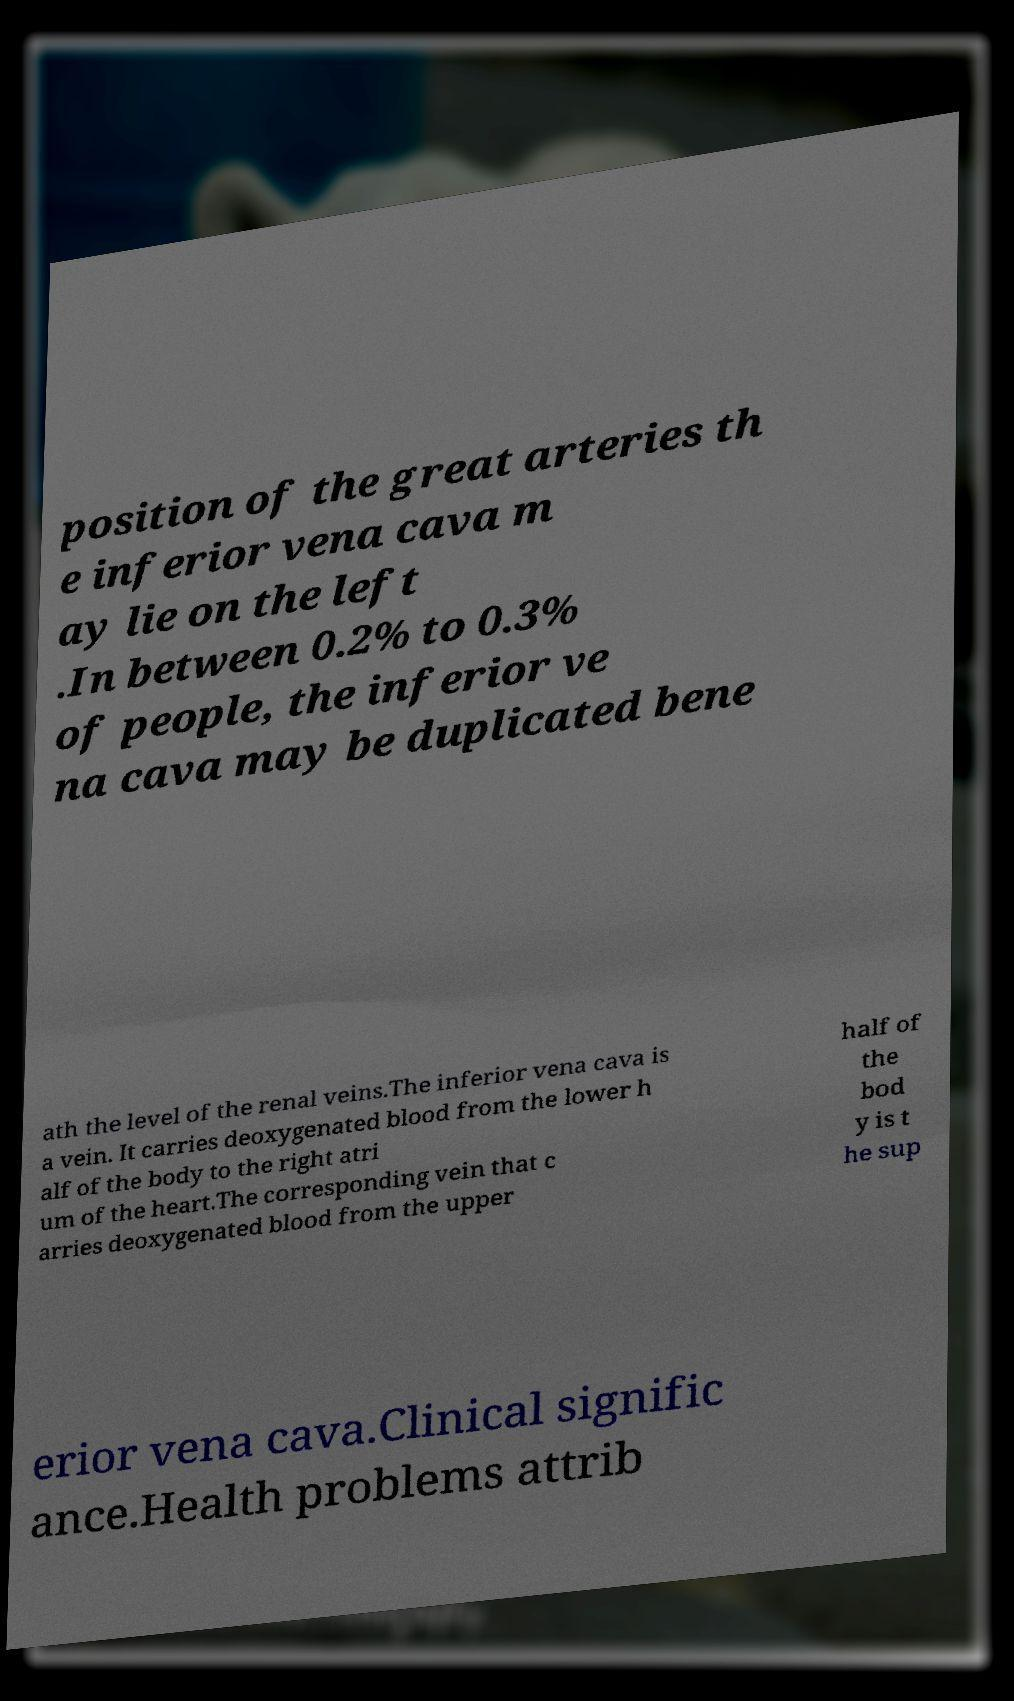I need the written content from this picture converted into text. Can you do that? position of the great arteries th e inferior vena cava m ay lie on the left .In between 0.2% to 0.3% of people, the inferior ve na cava may be duplicated bene ath the level of the renal veins.The inferior vena cava is a vein. It carries deoxygenated blood from the lower h alf of the body to the right atri um of the heart.The corresponding vein that c arries deoxygenated blood from the upper half of the bod y is t he sup erior vena cava.Clinical signific ance.Health problems attrib 